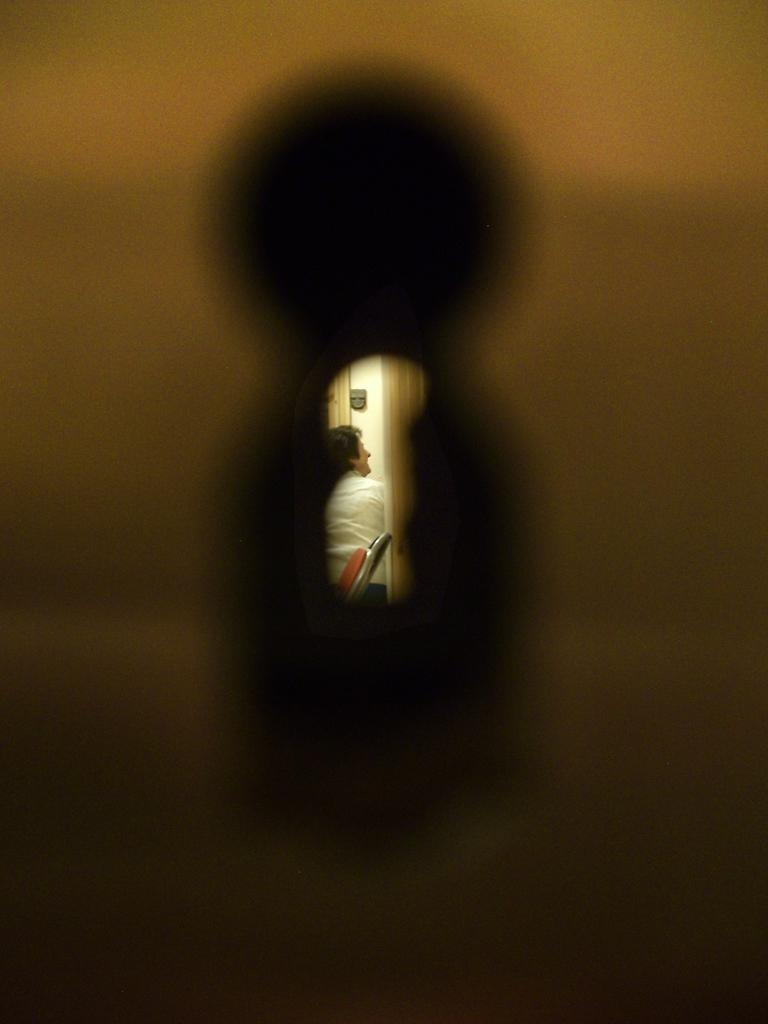What is the main feature of the image? There is a hole in the image. What can be seen through the hole? A person and other items are visible through the hole. Can you see a nest through the hole in the image? There is no mention of a nest in the image, so it cannot be seen through the hole. 